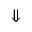Convert formula to latex. <formula><loc_0><loc_0><loc_500><loc_500>\Downarrow</formula> 